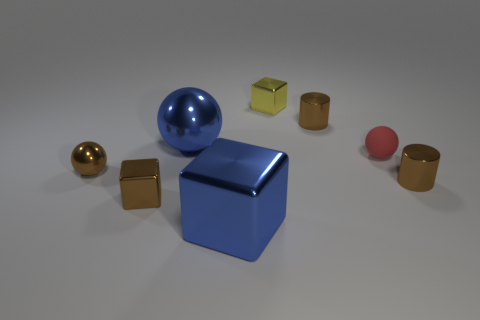Subtract all tiny yellow blocks. How many blocks are left? 2 Subtract 1 spheres. How many spheres are left? 2 Subtract all gray blocks. Subtract all gray cylinders. How many blocks are left? 3 Add 2 blocks. How many objects exist? 10 Subtract 0 red cylinders. How many objects are left? 8 Subtract all cylinders. How many objects are left? 6 Subtract all brown shiny cubes. Subtract all blue balls. How many objects are left? 6 Add 7 blue metal blocks. How many blue metal blocks are left? 8 Add 8 tiny metallic cylinders. How many tiny metallic cylinders exist? 10 